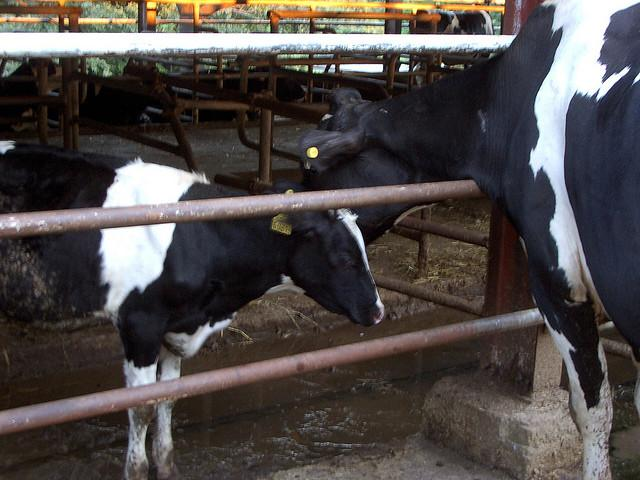Why is the mother cow in a different pen than her calf? Please explain your reasoning. safety. The mom is away from her calf for weaning. 